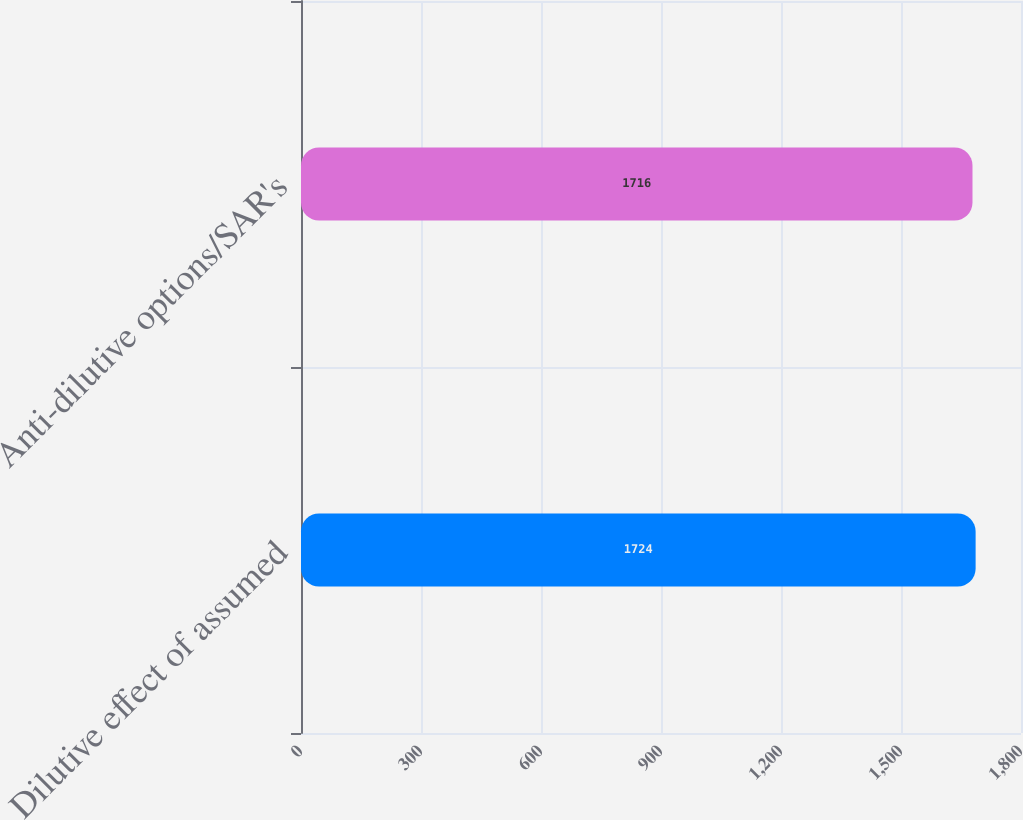Convert chart to OTSL. <chart><loc_0><loc_0><loc_500><loc_500><bar_chart><fcel>Dilutive effect of assumed<fcel>Anti-dilutive options/SAR's<nl><fcel>1724<fcel>1716<nl></chart> 